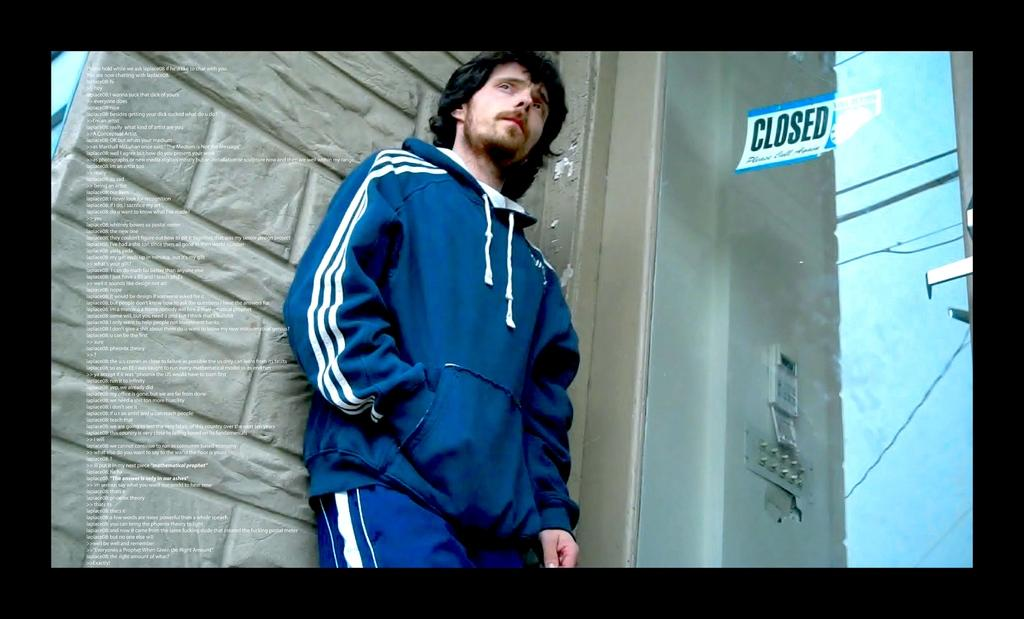<image>
Render a clear and concise summary of the photo. a person standing next to a closed sign 